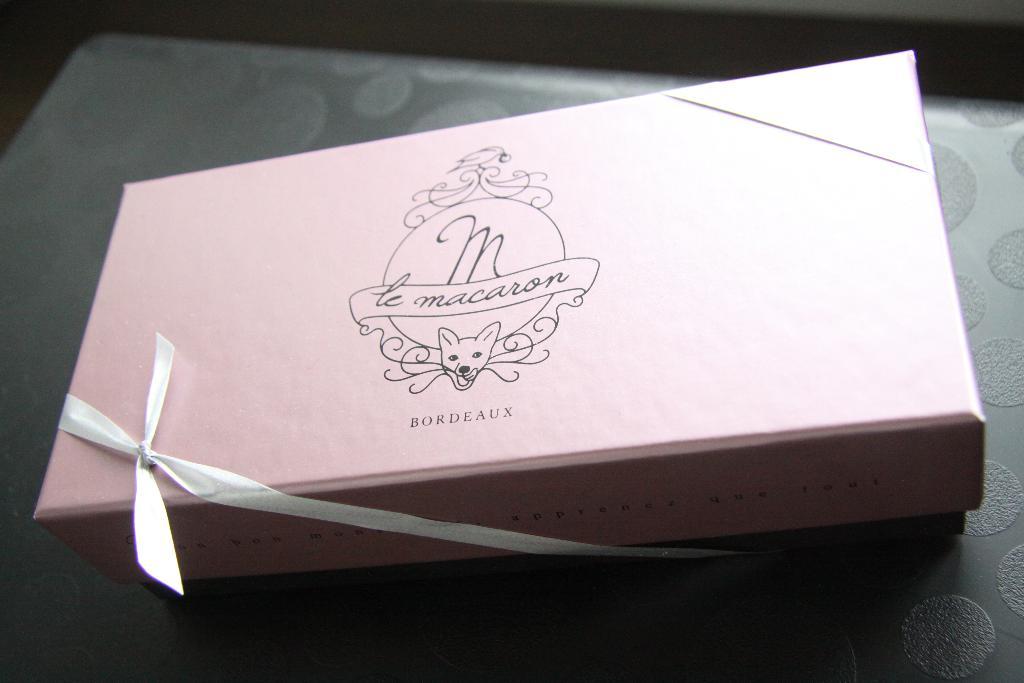What sweet is inside of the box?
Keep it short and to the point. Macaron. What company made the box?
Your answer should be compact. Bordeaux. 